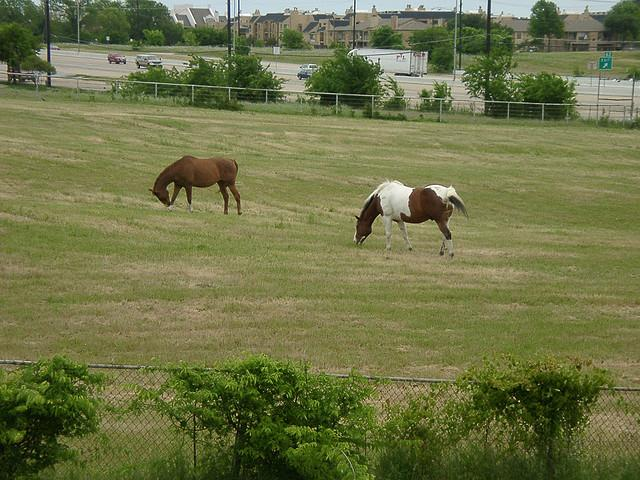What type of animals are present?

Choices:
A) deer
B) giraffe
C) dog
D) horse horse 